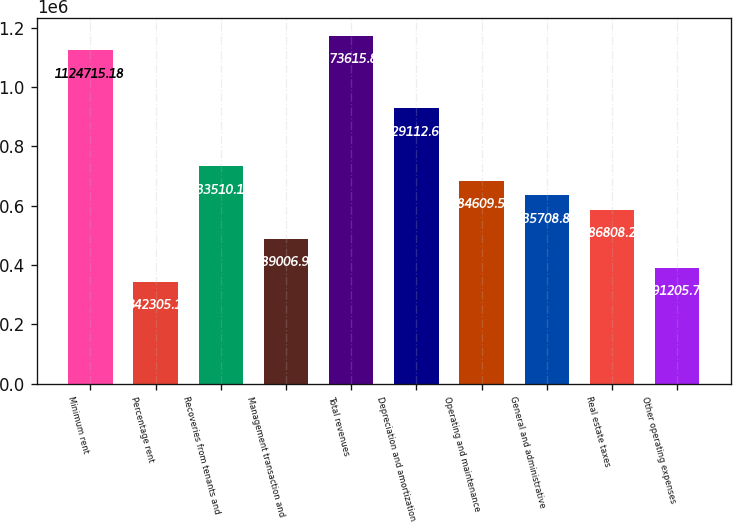Convert chart. <chart><loc_0><loc_0><loc_500><loc_500><bar_chart><fcel>Minimum rent<fcel>Percentage rent<fcel>Recoveries from tenants and<fcel>Management transaction and<fcel>Total revenues<fcel>Depreciation and amortization<fcel>Operating and maintenance<fcel>General and administrative<fcel>Real estate taxes<fcel>Other operating expenses<nl><fcel>1.12472e+06<fcel>342305<fcel>733510<fcel>489007<fcel>1.17362e+06<fcel>929113<fcel>684610<fcel>635709<fcel>586808<fcel>391206<nl></chart> 